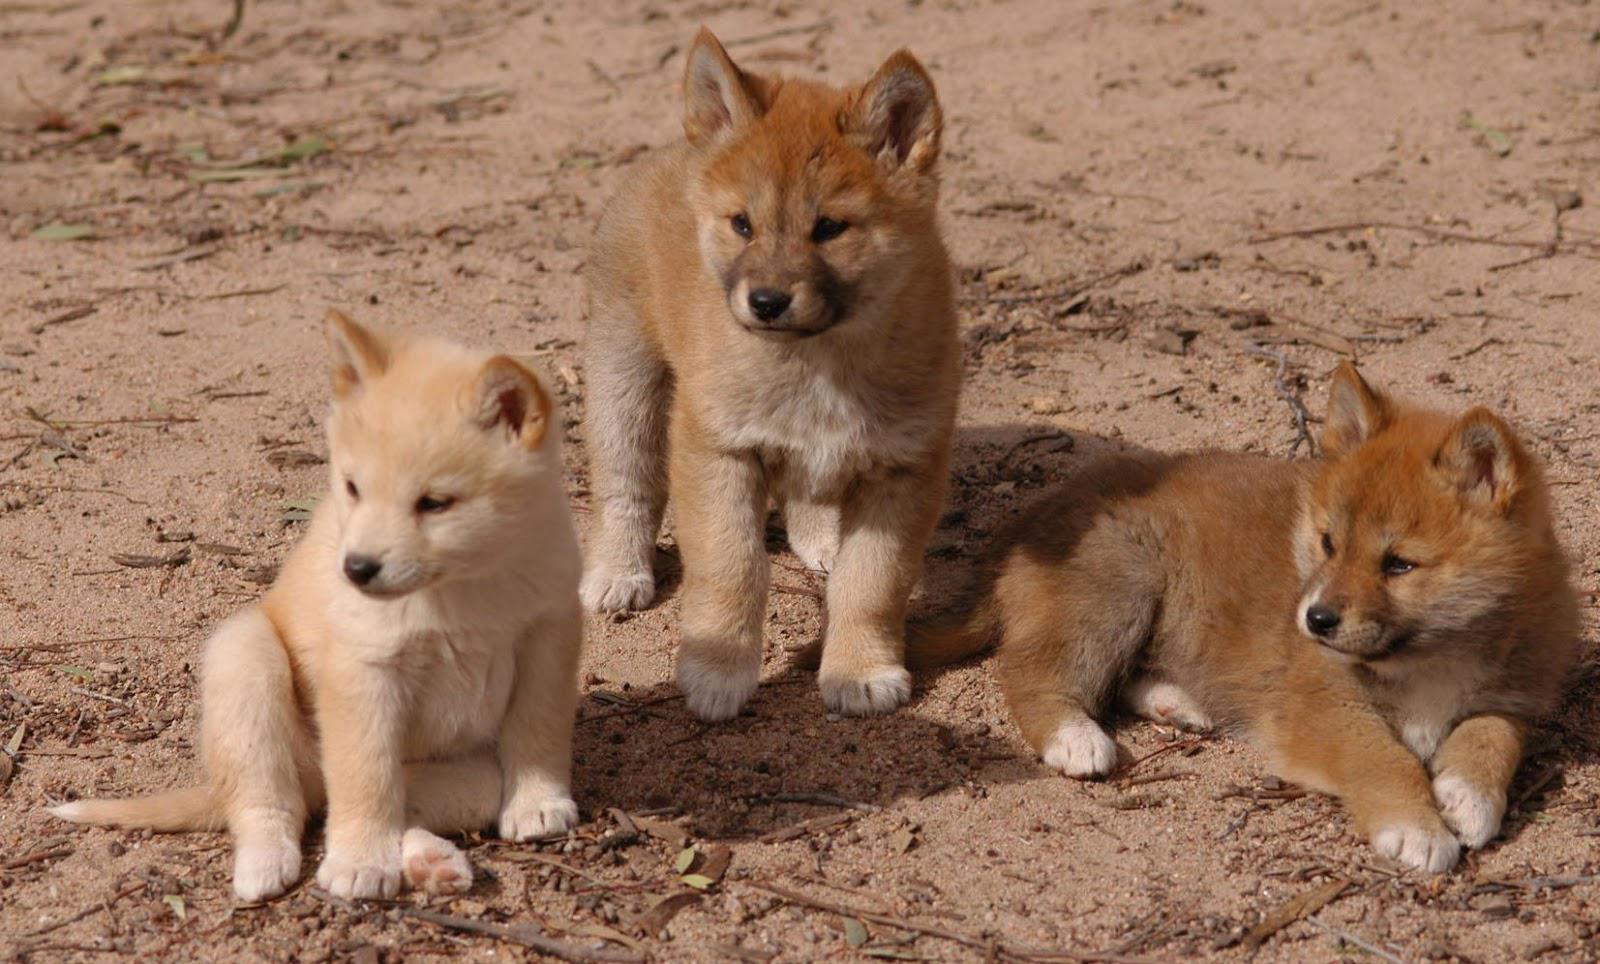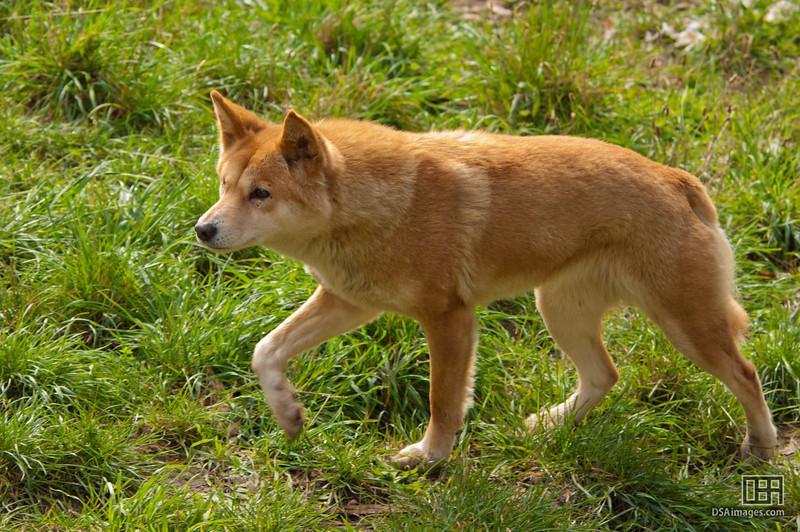The first image is the image on the left, the second image is the image on the right. Examine the images to the left and right. Is the description "A dog is walking through the grass in one of the images." accurate? Answer yes or no. Yes. The first image is the image on the left, the second image is the image on the right. For the images displayed, is the sentence "An image shows one wild dog walking leftward across green grass." factually correct? Answer yes or no. Yes. 